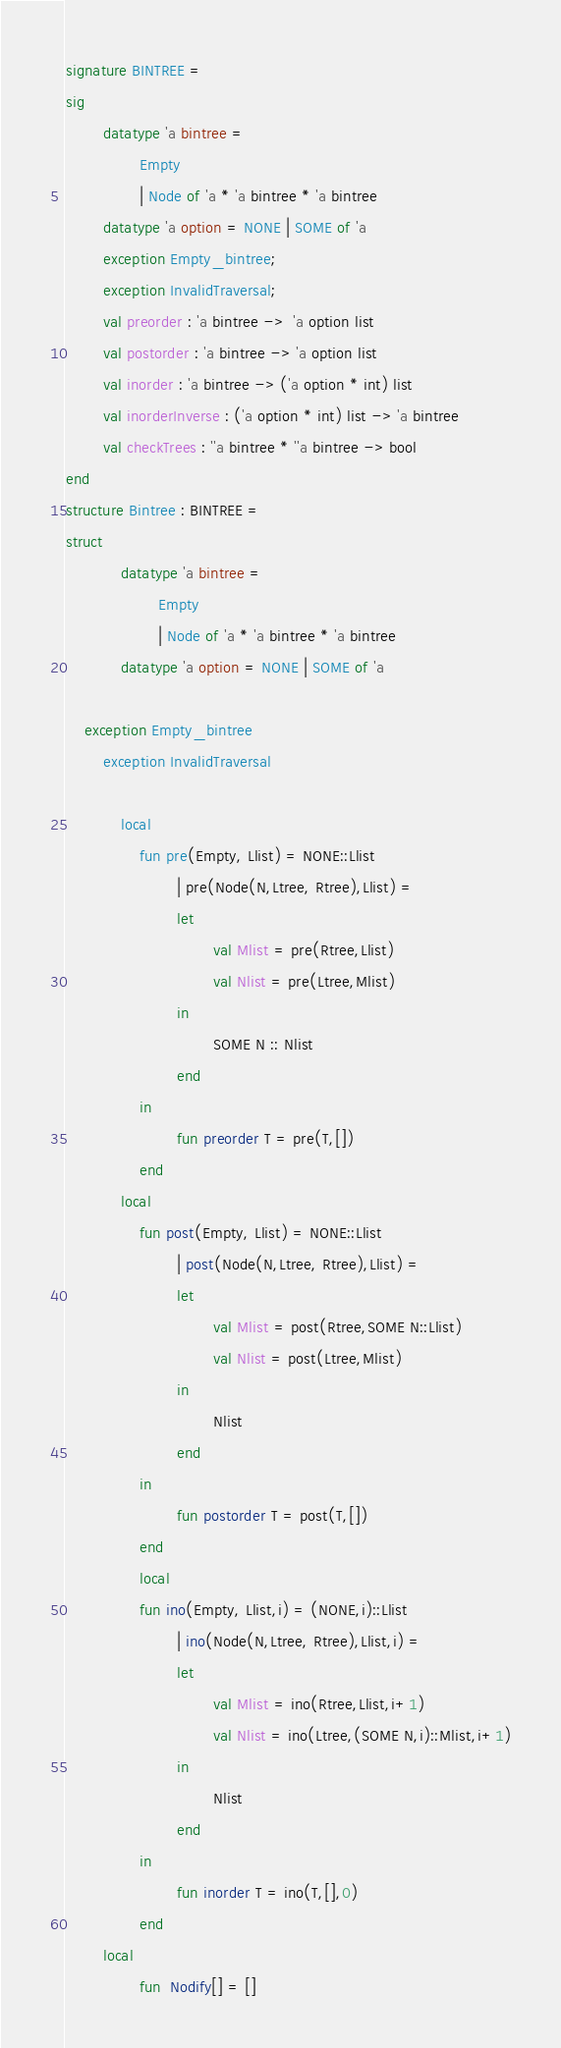<code> <loc_0><loc_0><loc_500><loc_500><_SML_>signature BINTREE = 
sig
        datatype 'a bintree = 
                Empty 
                | Node of 'a * 'a bintree * 'a bintree
        datatype 'a option = NONE | SOME of 'a
        exception Empty_bintree;
        exception InvalidTraversal;
        val preorder : 'a bintree ->  'a option list
        val postorder : 'a bintree -> 'a option list
        val inorder : 'a bintree -> ('a option * int) list
        val inorderInverse : ('a option * int) list -> 'a bintree
        val checkTrees : ''a bintree * ''a bintree -> bool
end
structure Bintree : BINTREE = 
struct
            datatype 'a bintree = 
                    Empty 
                    | Node of 'a * 'a bintree * 'a bintree
            datatype 'a option = NONE | SOME of 'a
    
    exception Empty_bintree
        exception InvalidTraversal
        
            local 
                fun pre(Empty, Llist) = NONE::Llist
                        | pre(Node(N,Ltree, Rtree),Llist) = 
                        let
                                val Mlist = pre(Rtree,Llist)
                                val Nlist = pre(Ltree,Mlist)
                        in
                                SOME N :: Nlist
                        end
                in 
                        fun preorder T = pre(T,[])
                end
            local 
                fun post(Empty, Llist) = NONE::Llist
                        | post(Node(N,Ltree, Rtree),Llist) = 
                        let
                                val Mlist = post(Rtree,SOME N::Llist)
                                val Nlist = post(Ltree,Mlist)
                        in
                                Nlist
                        end
                in 
                        fun postorder T = post(T,[])
                end
                local 
                fun ino(Empty, Llist,i) = (NONE,i)::Llist
                        | ino(Node(N,Ltree, Rtree),Llist,i) = 
                        let
                                val Mlist = ino(Rtree,Llist,i+1)
                                val Nlist = ino(Ltree,(SOME N,i)::Mlist,i+1)
                        in
                                Nlist
                        end
                in 
                        fun inorder T = ino(T,[],0)
                end
        local
                fun  Nodify[] = []</code> 